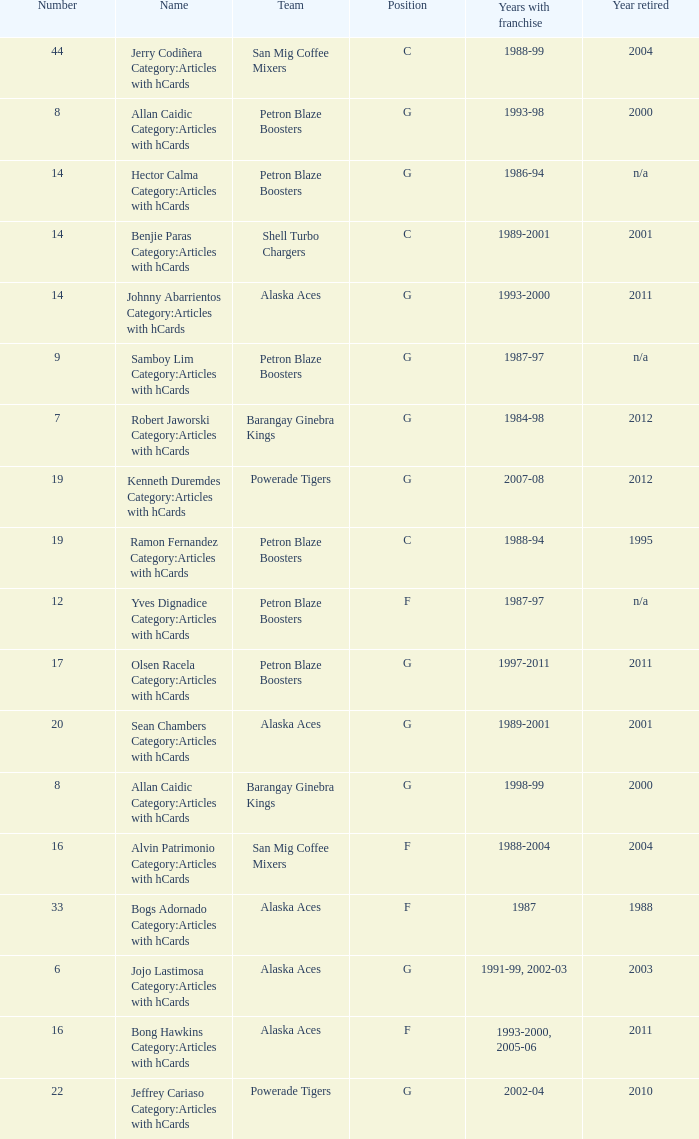Who was the player in Position G on the Petron Blaze Boosters and retired in 2000? Allan Caidic Category:Articles with hCards. 